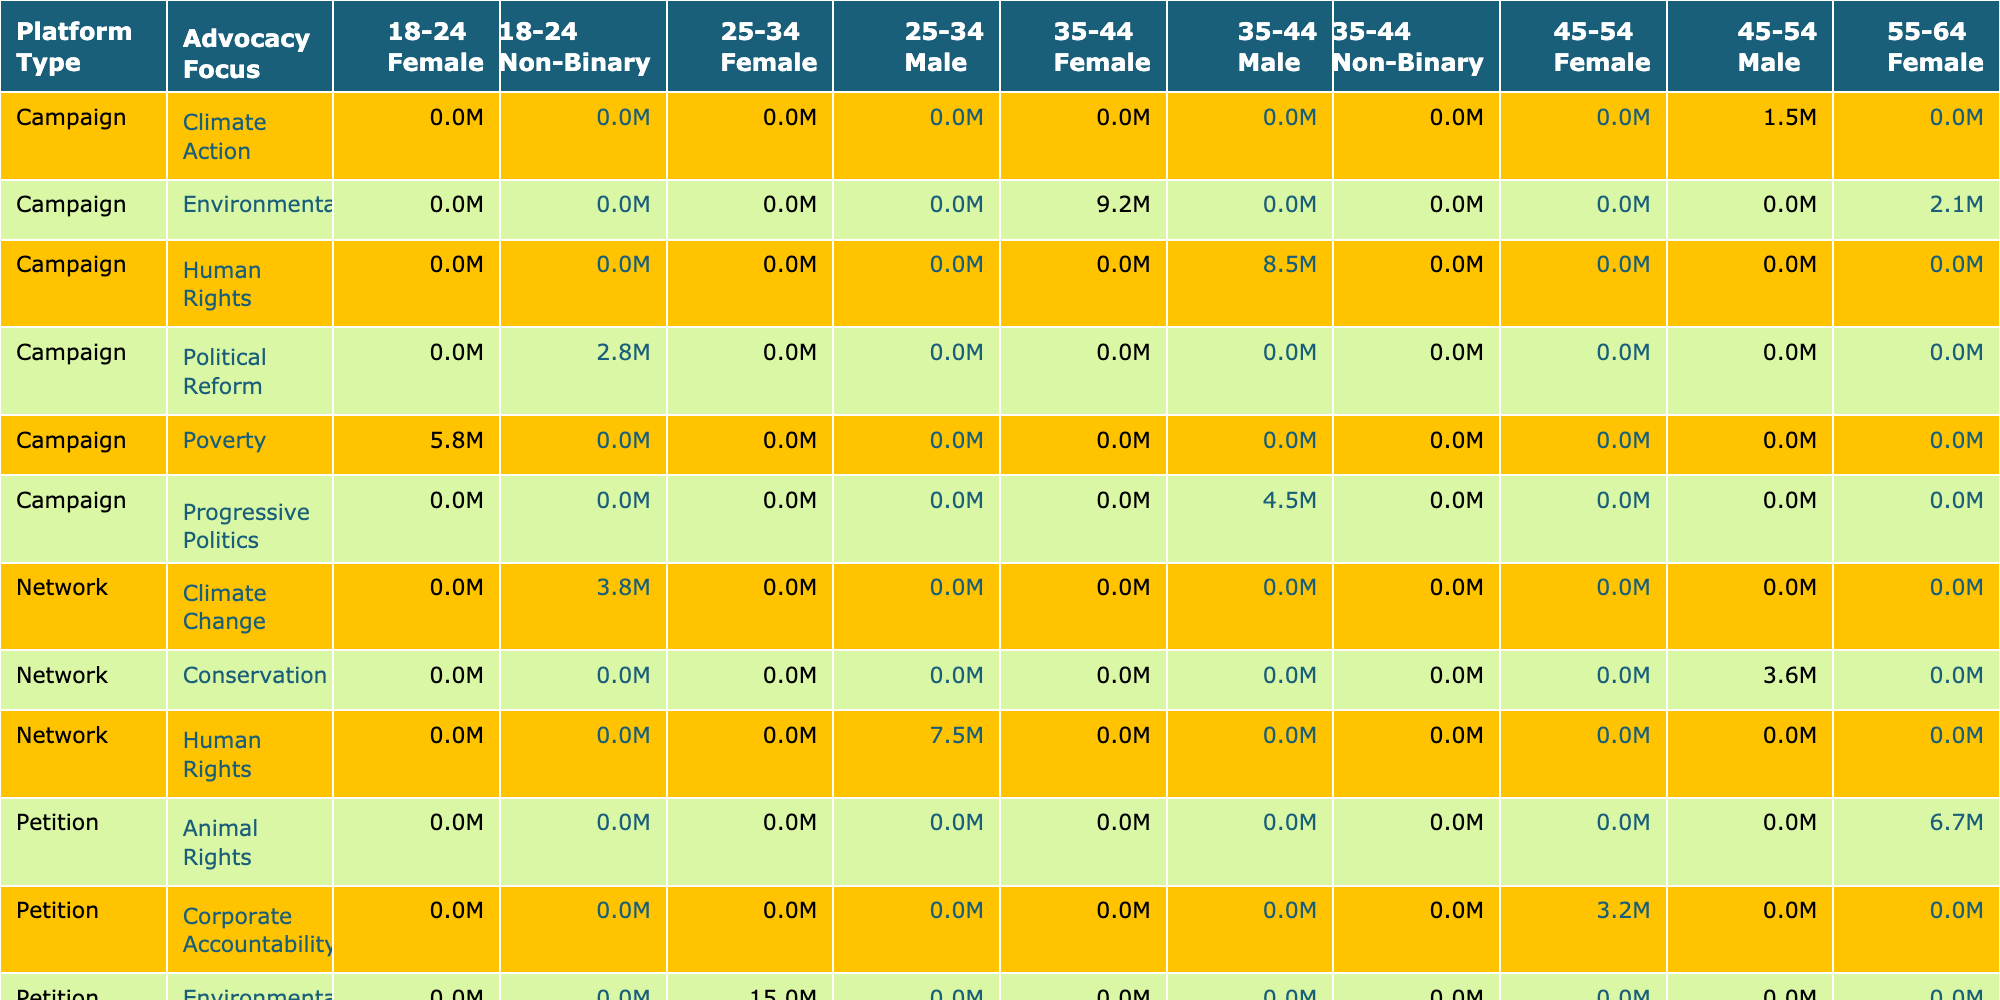What is the total number of monthly users for advocacy platforms focused on environmental issues? To find the total number of monthly users for platforms focusing on environmental issues, we identify the relevant rows in the table: Change.org with 15 million users, Greenpeace with 9.2 million users, and Friends of the Earth with 2.1 million users. Adding these values together: 15 + 9.2 + 2.1 = 26.3 million users.
Answer: 26.3 million Which age group has the highest engagement rate in the table? By examining the engagement rates provided in the table per age group: 25-34 has rates of 7.2%, 6.9%; 35-44 has rates of 6.8%, 7.5%, and 6.7%; 18-24 has rates of 8.1% and 7.6%; 45-54 has rates of 5.9%, 6.3%, and 5.7%; 55-64 has 5.4% and 5.8%. The highest rate, 8.1%, corresponds to the age group 18-24.
Answer: 18-24 Is there any platform type that exclusively focuses on Human Rights? The table lists platforms under different types, and both Avaaz and Amnesty International are identified as 'Campaign' and 'Network', respectively. Since no platform type is exclusively dedicated to Human Rights, the answer is no.
Answer: No What is the average monthly user count for petition platforms? The monthly user counts for petition platforms are: Change.org (15 million), SumOfUs (3.2 million), Care2 (6.7 million), GetUp! (1.9 million), and CREDO Action (2.4 million). The total user count is 15 + 3.2 + 6.7 + 1.9 + 2.4 = 29.2 million. Since there are 5 platforms, the average is 29.2 million / 5 = 5.84 million.
Answer: 5.84 million Which advocacy focus has the least total number of monthly users across all platforms? Looking at the totals per advocacy focus: Environmental (26.3 million), Human Rights (15.7 million), Corporate Accountability (3.2 million), Political Reform (2.8 million), Animal Rights (6.7 million), Progressive Politics (4.5 million), Conservation (3.6 million), Climate Action (1.5 million), and Poverty (5.8 million). The lowest count is 3.2 million for Corporate Accountability.
Answer: Corporate Accountability Which gender demographic has more monthly users in total across all platforms? By analyzing the totals, Female demographics include Change.org (15), SumOfUs (3.2), Care2 (6.7), GetUp! (1.9), Greenpeace (9.2), Friends of the Earth (2.1), and Amnesty International (7.5), giving a total of 45.1 million. For Male demographics: Avaaz (8.5), MoveOn (4.5), Campact (1.5), Sierra Club (3.6), and CREDO Action (2.4), yielding 20.5 million. Since 45.1 million > 20.5 million, the answer is Female.
Answer: Female What is the engagement rate for the campaign type platforms that focus on Climate Change? The only platform that focuses on Climate Change is 350.org, which has an engagement rate of 8.1%. Looking at the table, engagement rates for campaign types such as Greenpeace (7.5%) and MoveOn (7.8%) do not share this focus, making it necessary to escape from comparison. Thus, the engagement rate for Climate Change remains 8.1%.
Answer: 8.1% How many platforms have a higher engagement rate than 7%? To find the number of platforms with an engagement rate above 7%, we list out those rates from the table: 7.2%, 7.8%, 7.5%, 8.1%, and 7.6%. Thus, the counts are 5 instances above 7%.
Answer: 5 platforms 